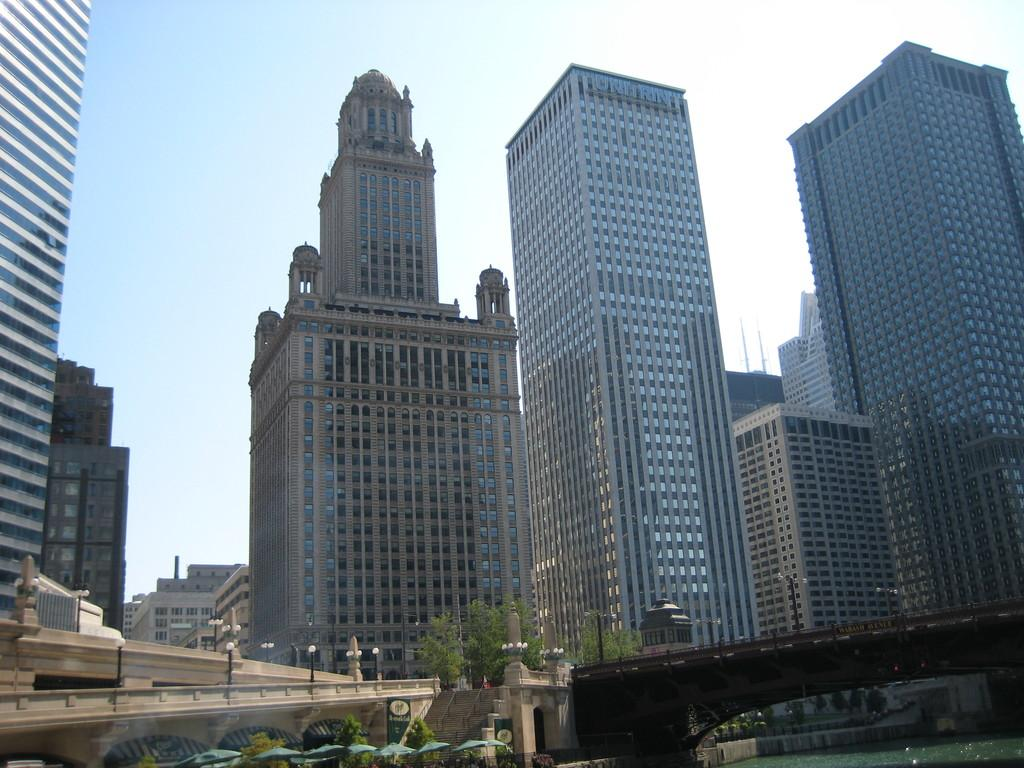What objects are present in the image to protect against rain? There are umbrellas in the image. What natural element is visible in the image? There is water visible in the image. What structure can be seen in the image that allows people to cross the water? There is a bridge in the image. What type of vegetation is present in the image? There are trees in the image. What architectural feature can be seen in the image that allows for changes in elevation? There are stairs in the image. What type of man-made structures are visible in the image? There are buildings in the image. Can you see the feet of the people walking in the park in the image? There is no park or people walking present in the image. What type of park is visible in the image? There is no park present in the image. 